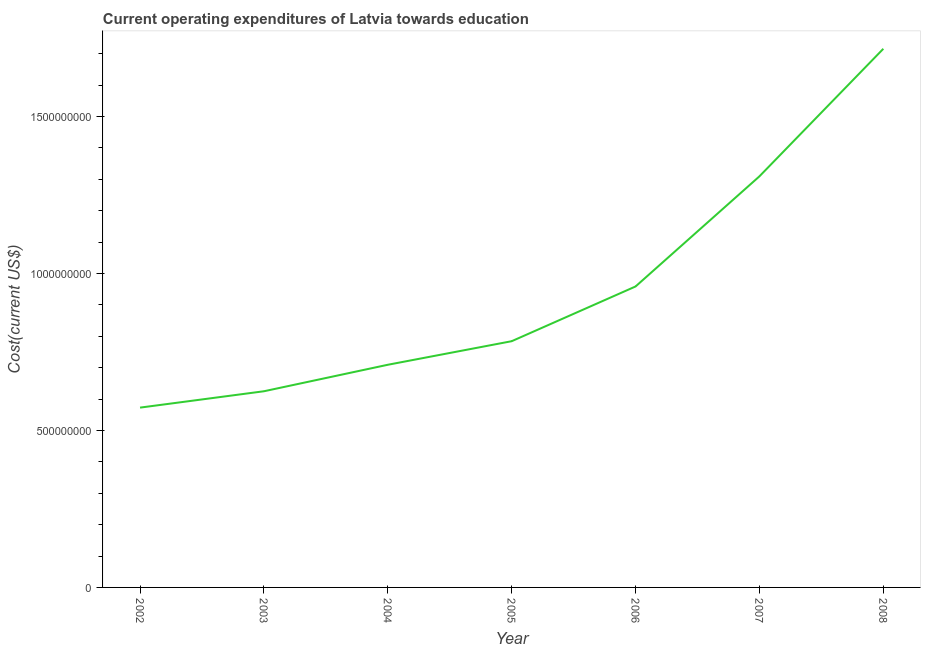What is the education expenditure in 2005?
Give a very brief answer. 7.84e+08. Across all years, what is the maximum education expenditure?
Offer a very short reply. 1.72e+09. Across all years, what is the minimum education expenditure?
Give a very brief answer. 5.73e+08. What is the sum of the education expenditure?
Your answer should be very brief. 6.68e+09. What is the difference between the education expenditure in 2003 and 2006?
Your answer should be very brief. -3.34e+08. What is the average education expenditure per year?
Your response must be concise. 9.54e+08. What is the median education expenditure?
Your answer should be very brief. 7.84e+08. In how many years, is the education expenditure greater than 600000000 US$?
Give a very brief answer. 6. What is the ratio of the education expenditure in 2006 to that in 2007?
Provide a succinct answer. 0.73. What is the difference between the highest and the second highest education expenditure?
Make the answer very short. 4.06e+08. What is the difference between the highest and the lowest education expenditure?
Your answer should be very brief. 1.14e+09. Does the education expenditure monotonically increase over the years?
Your answer should be compact. Yes. What is the difference between two consecutive major ticks on the Y-axis?
Give a very brief answer. 5.00e+08. Are the values on the major ticks of Y-axis written in scientific E-notation?
Your answer should be compact. No. Does the graph contain any zero values?
Provide a short and direct response. No. Does the graph contain grids?
Ensure brevity in your answer.  No. What is the title of the graph?
Your answer should be very brief. Current operating expenditures of Latvia towards education. What is the label or title of the Y-axis?
Make the answer very short. Cost(current US$). What is the Cost(current US$) in 2002?
Make the answer very short. 5.73e+08. What is the Cost(current US$) of 2003?
Offer a terse response. 6.25e+08. What is the Cost(current US$) in 2004?
Provide a short and direct response. 7.09e+08. What is the Cost(current US$) of 2005?
Ensure brevity in your answer.  7.84e+08. What is the Cost(current US$) in 2006?
Your answer should be compact. 9.59e+08. What is the Cost(current US$) in 2007?
Offer a very short reply. 1.31e+09. What is the Cost(current US$) in 2008?
Ensure brevity in your answer.  1.72e+09. What is the difference between the Cost(current US$) in 2002 and 2003?
Your answer should be compact. -5.21e+07. What is the difference between the Cost(current US$) in 2002 and 2004?
Provide a short and direct response. -1.36e+08. What is the difference between the Cost(current US$) in 2002 and 2005?
Give a very brief answer. -2.12e+08. What is the difference between the Cost(current US$) in 2002 and 2006?
Offer a terse response. -3.86e+08. What is the difference between the Cost(current US$) in 2002 and 2007?
Provide a succinct answer. -7.37e+08. What is the difference between the Cost(current US$) in 2002 and 2008?
Offer a terse response. -1.14e+09. What is the difference between the Cost(current US$) in 2003 and 2004?
Your answer should be compact. -8.44e+07. What is the difference between the Cost(current US$) in 2003 and 2005?
Keep it short and to the point. -1.59e+08. What is the difference between the Cost(current US$) in 2003 and 2006?
Provide a short and direct response. -3.34e+08. What is the difference between the Cost(current US$) in 2003 and 2007?
Your answer should be compact. -6.85e+08. What is the difference between the Cost(current US$) in 2003 and 2008?
Your response must be concise. -1.09e+09. What is the difference between the Cost(current US$) in 2004 and 2005?
Ensure brevity in your answer.  -7.51e+07. What is the difference between the Cost(current US$) in 2004 and 2006?
Provide a short and direct response. -2.49e+08. What is the difference between the Cost(current US$) in 2004 and 2007?
Give a very brief answer. -6.00e+08. What is the difference between the Cost(current US$) in 2004 and 2008?
Your answer should be very brief. -1.01e+09. What is the difference between the Cost(current US$) in 2005 and 2006?
Ensure brevity in your answer.  -1.74e+08. What is the difference between the Cost(current US$) in 2005 and 2007?
Provide a succinct answer. -5.25e+08. What is the difference between the Cost(current US$) in 2005 and 2008?
Provide a succinct answer. -9.32e+08. What is the difference between the Cost(current US$) in 2006 and 2007?
Offer a terse response. -3.51e+08. What is the difference between the Cost(current US$) in 2006 and 2008?
Your response must be concise. -7.57e+08. What is the difference between the Cost(current US$) in 2007 and 2008?
Offer a very short reply. -4.06e+08. What is the ratio of the Cost(current US$) in 2002 to that in 2003?
Ensure brevity in your answer.  0.92. What is the ratio of the Cost(current US$) in 2002 to that in 2004?
Offer a very short reply. 0.81. What is the ratio of the Cost(current US$) in 2002 to that in 2005?
Give a very brief answer. 0.73. What is the ratio of the Cost(current US$) in 2002 to that in 2006?
Provide a short and direct response. 0.6. What is the ratio of the Cost(current US$) in 2002 to that in 2007?
Your answer should be compact. 0.44. What is the ratio of the Cost(current US$) in 2002 to that in 2008?
Offer a terse response. 0.33. What is the ratio of the Cost(current US$) in 2003 to that in 2004?
Ensure brevity in your answer.  0.88. What is the ratio of the Cost(current US$) in 2003 to that in 2005?
Ensure brevity in your answer.  0.8. What is the ratio of the Cost(current US$) in 2003 to that in 2006?
Make the answer very short. 0.65. What is the ratio of the Cost(current US$) in 2003 to that in 2007?
Provide a short and direct response. 0.48. What is the ratio of the Cost(current US$) in 2003 to that in 2008?
Provide a short and direct response. 0.36. What is the ratio of the Cost(current US$) in 2004 to that in 2005?
Ensure brevity in your answer.  0.9. What is the ratio of the Cost(current US$) in 2004 to that in 2006?
Keep it short and to the point. 0.74. What is the ratio of the Cost(current US$) in 2004 to that in 2007?
Give a very brief answer. 0.54. What is the ratio of the Cost(current US$) in 2004 to that in 2008?
Provide a succinct answer. 0.41. What is the ratio of the Cost(current US$) in 2005 to that in 2006?
Provide a short and direct response. 0.82. What is the ratio of the Cost(current US$) in 2005 to that in 2007?
Your answer should be very brief. 0.6. What is the ratio of the Cost(current US$) in 2005 to that in 2008?
Offer a very short reply. 0.46. What is the ratio of the Cost(current US$) in 2006 to that in 2007?
Make the answer very short. 0.73. What is the ratio of the Cost(current US$) in 2006 to that in 2008?
Make the answer very short. 0.56. What is the ratio of the Cost(current US$) in 2007 to that in 2008?
Offer a terse response. 0.76. 